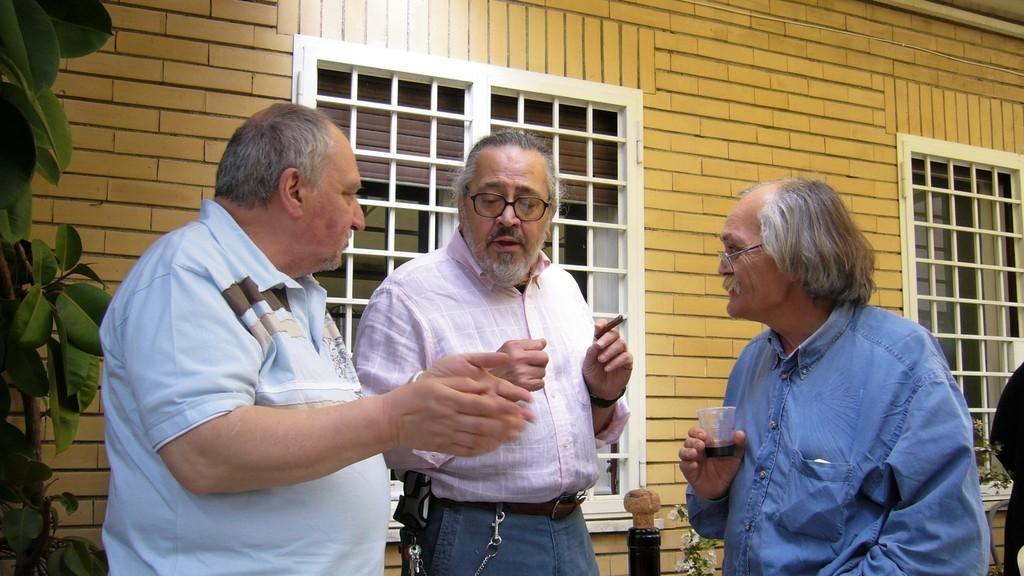How many people are present in the image? There are three people in the image. What objects are being held by the people? One person is holding a glass, and another person is holding a cigar. How many windows can be seen in the image? There are two windows visible in the image. What else is present in the image besides the people and windows? There are plants in the image. What type of structure is being built by the people in the image using a quill? There is no structure being built in the image, nor is there a quill present. 